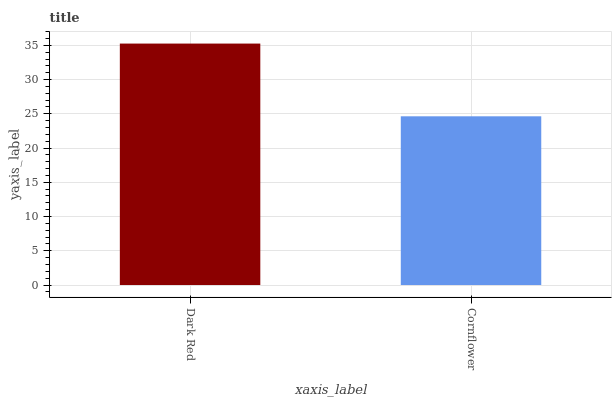Is Cornflower the minimum?
Answer yes or no. Yes. Is Dark Red the maximum?
Answer yes or no. Yes. Is Cornflower the maximum?
Answer yes or no. No. Is Dark Red greater than Cornflower?
Answer yes or no. Yes. Is Cornflower less than Dark Red?
Answer yes or no. Yes. Is Cornflower greater than Dark Red?
Answer yes or no. No. Is Dark Red less than Cornflower?
Answer yes or no. No. Is Dark Red the high median?
Answer yes or no. Yes. Is Cornflower the low median?
Answer yes or no. Yes. Is Cornflower the high median?
Answer yes or no. No. Is Dark Red the low median?
Answer yes or no. No. 